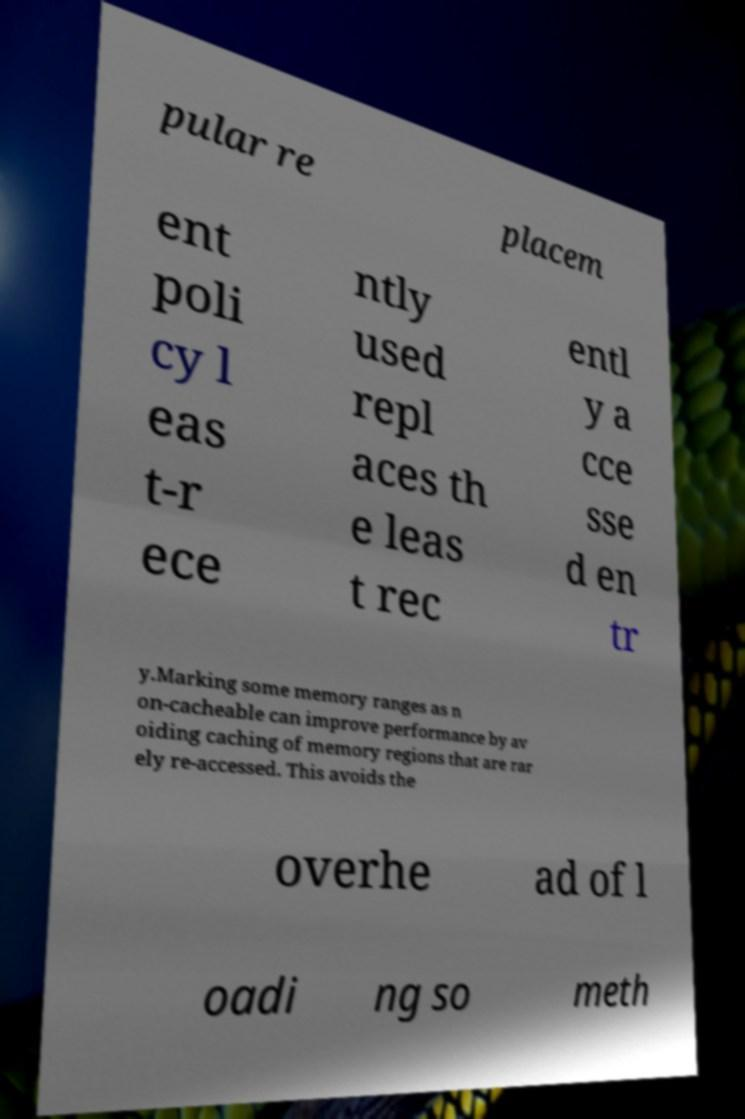For documentation purposes, I need the text within this image transcribed. Could you provide that? pular re placem ent poli cy l eas t-r ece ntly used repl aces th e leas t rec entl y a cce sse d en tr y.Marking some memory ranges as n on-cacheable can improve performance by av oiding caching of memory regions that are rar ely re-accessed. This avoids the overhe ad of l oadi ng so meth 